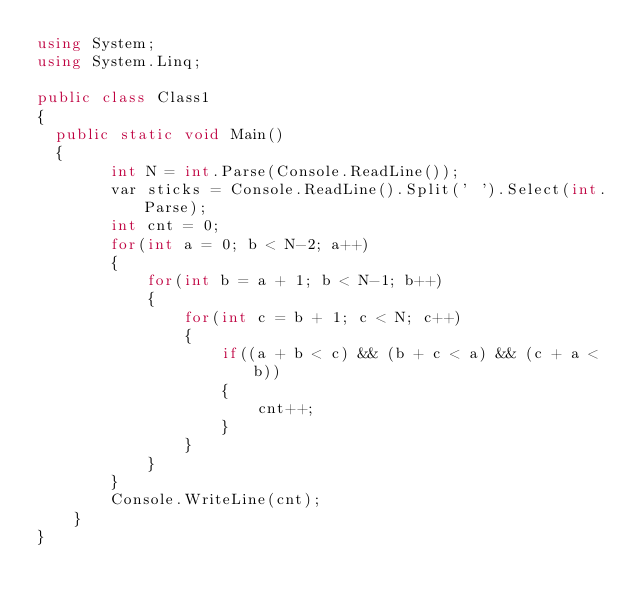<code> <loc_0><loc_0><loc_500><loc_500><_C#_>using System;
using System.Linq;

public class Class1
{
	public static void Main()
	{
        int N = int.Parse(Console.ReadLine());
        var sticks = Console.ReadLine().Split(' ').Select(int.Parse);
        int cnt = 0;
        for(int a = 0; b < N-2; a++)
        {
            for(int b = a + 1; b < N-1; b++)
            {
                for(int c = b + 1; c < N; c++)
                {
                    if((a + b < c) && (b + c < a) && (c + a < b))
                    {
                        cnt++;
                    }
                }
            }
        }
        Console.WriteLine(cnt);
    }
}
</code> 